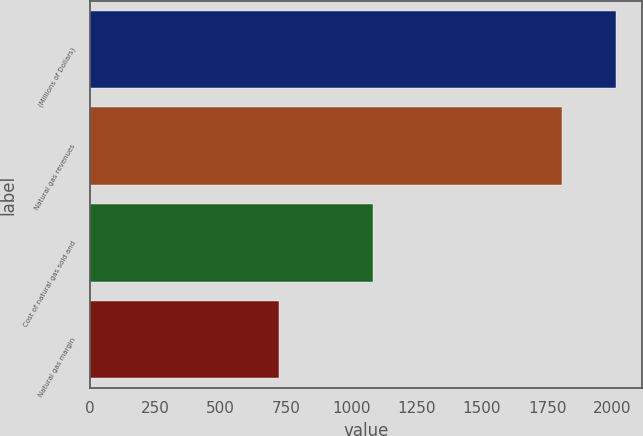Convert chart. <chart><loc_0><loc_0><loc_500><loc_500><bar_chart><fcel>(Millions of Dollars)<fcel>Natural gas revenues<fcel>Cost of natural gas sold and<fcel>Natural gas margin<nl><fcel>2013<fcel>1805<fcel>1083<fcel>722<nl></chart> 